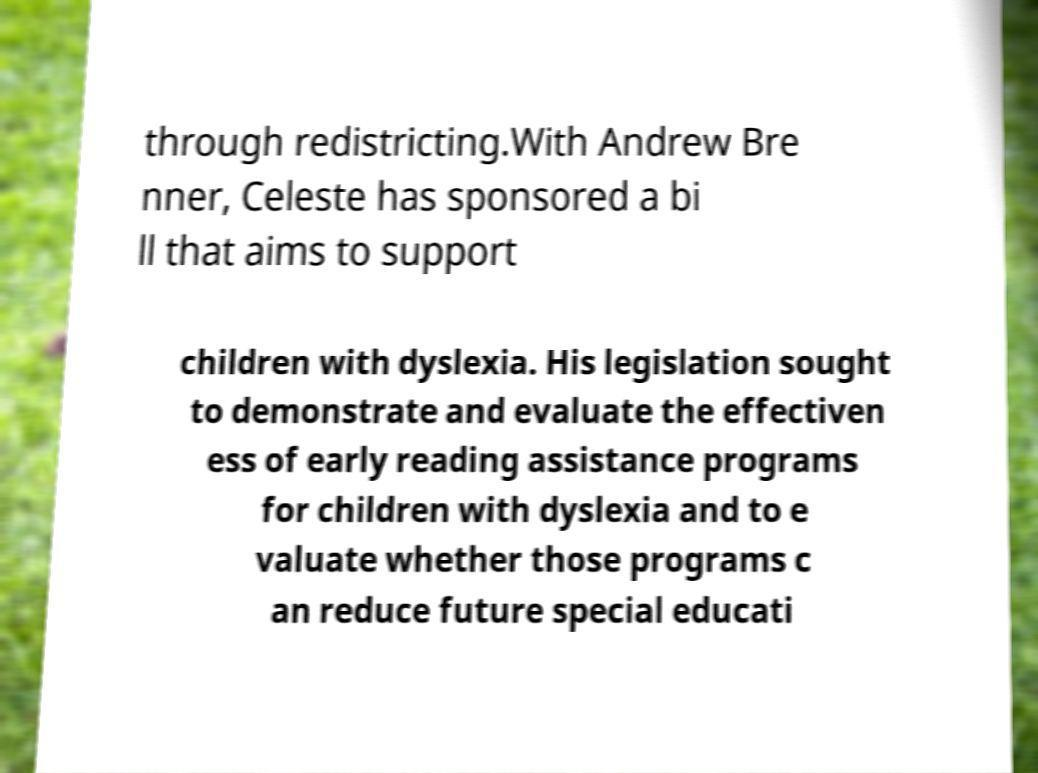Please read and relay the text visible in this image. What does it say? through redistricting.With Andrew Bre nner, Celeste has sponsored a bi ll that aims to support children with dyslexia. His legislation sought to demonstrate and evaluate the effectiven ess of early reading assistance programs for children with dyslexia and to e valuate whether those programs c an reduce future special educati 